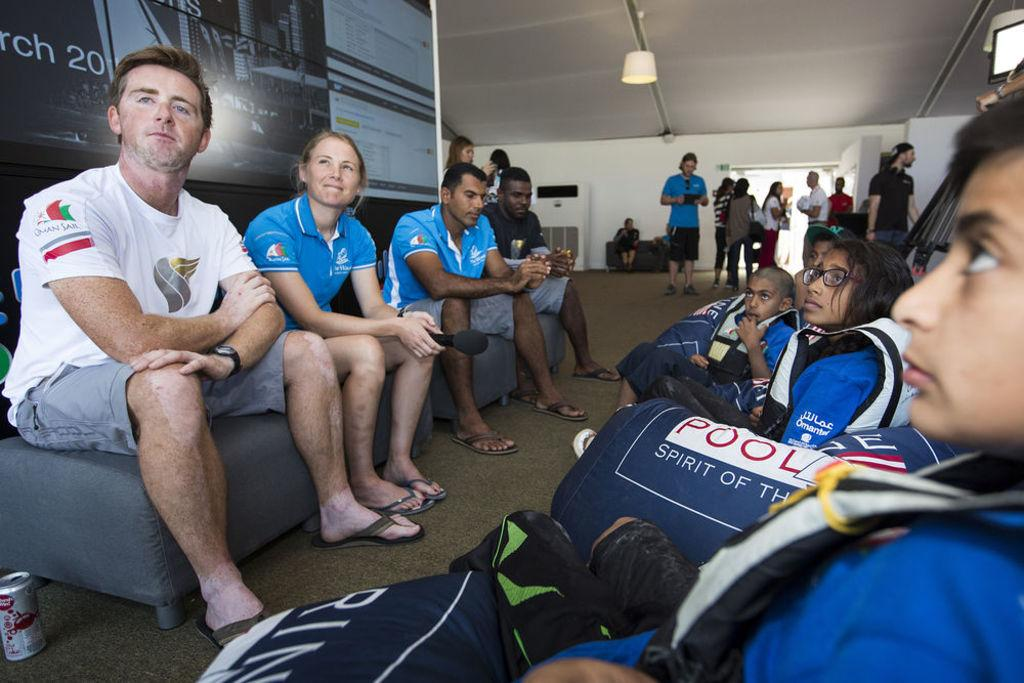<image>
Provide a brief description of the given image. Children are shown wearing vests and there is a logo that says "Pool." 